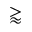Convert formula to latex. <formula><loc_0><loc_0><loc_500><loc_500>\gtrapprox</formula> 